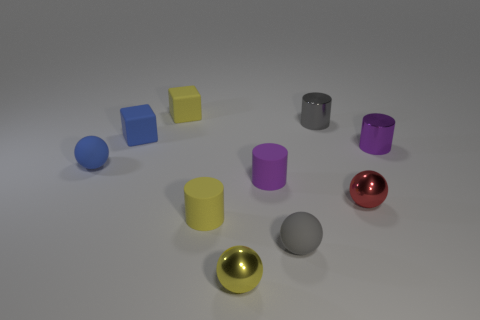How many different colors do you see in the image? In the image, I see seven different colors across various objects. They include blue, yellow, gray, purple, gold, red, and a light gray or silver. Which shapes appear the same number of times in the image? The shapes that appear with equal frequency are the cylinders; there are four of them in the image. 